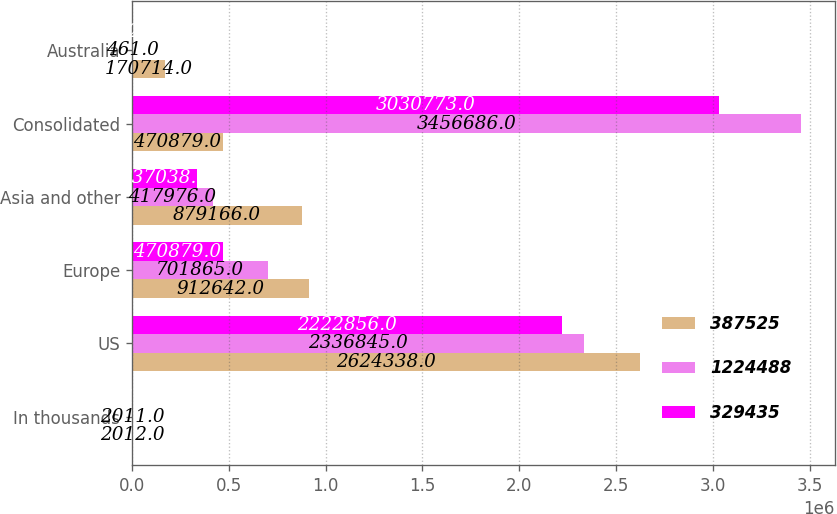<chart> <loc_0><loc_0><loc_500><loc_500><stacked_bar_chart><ecel><fcel>In thousands<fcel>US<fcel>Europe<fcel>Asia and other<fcel>Consolidated<fcel>Australia<nl><fcel>387525<fcel>2012<fcel>2.62434e+06<fcel>912642<fcel>879166<fcel>470879<fcel>170714<nl><fcel>1.22449e+06<fcel>2011<fcel>2.33684e+06<fcel>701865<fcel>417976<fcel>3.45669e+06<fcel>461<nl><fcel>329435<fcel>2010<fcel>2.22286e+06<fcel>470879<fcel>337038<fcel>3.03077e+06<fcel>772<nl></chart> 